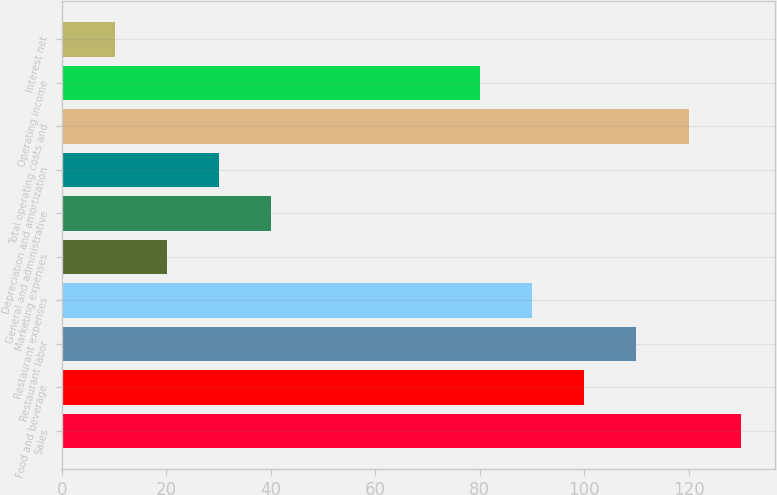Convert chart. <chart><loc_0><loc_0><loc_500><loc_500><bar_chart><fcel>Sales<fcel>Food and beverage<fcel>Restaurant labor<fcel>Restaurant expenses<fcel>Marketing expenses<fcel>General and administrative<fcel>Depreciation and amortization<fcel>Total operating costs and<fcel>Operating income<fcel>Interest net<nl><fcel>129.97<fcel>100<fcel>109.99<fcel>90.01<fcel>20.08<fcel>40.06<fcel>30.07<fcel>119.98<fcel>80.02<fcel>10.09<nl></chart> 